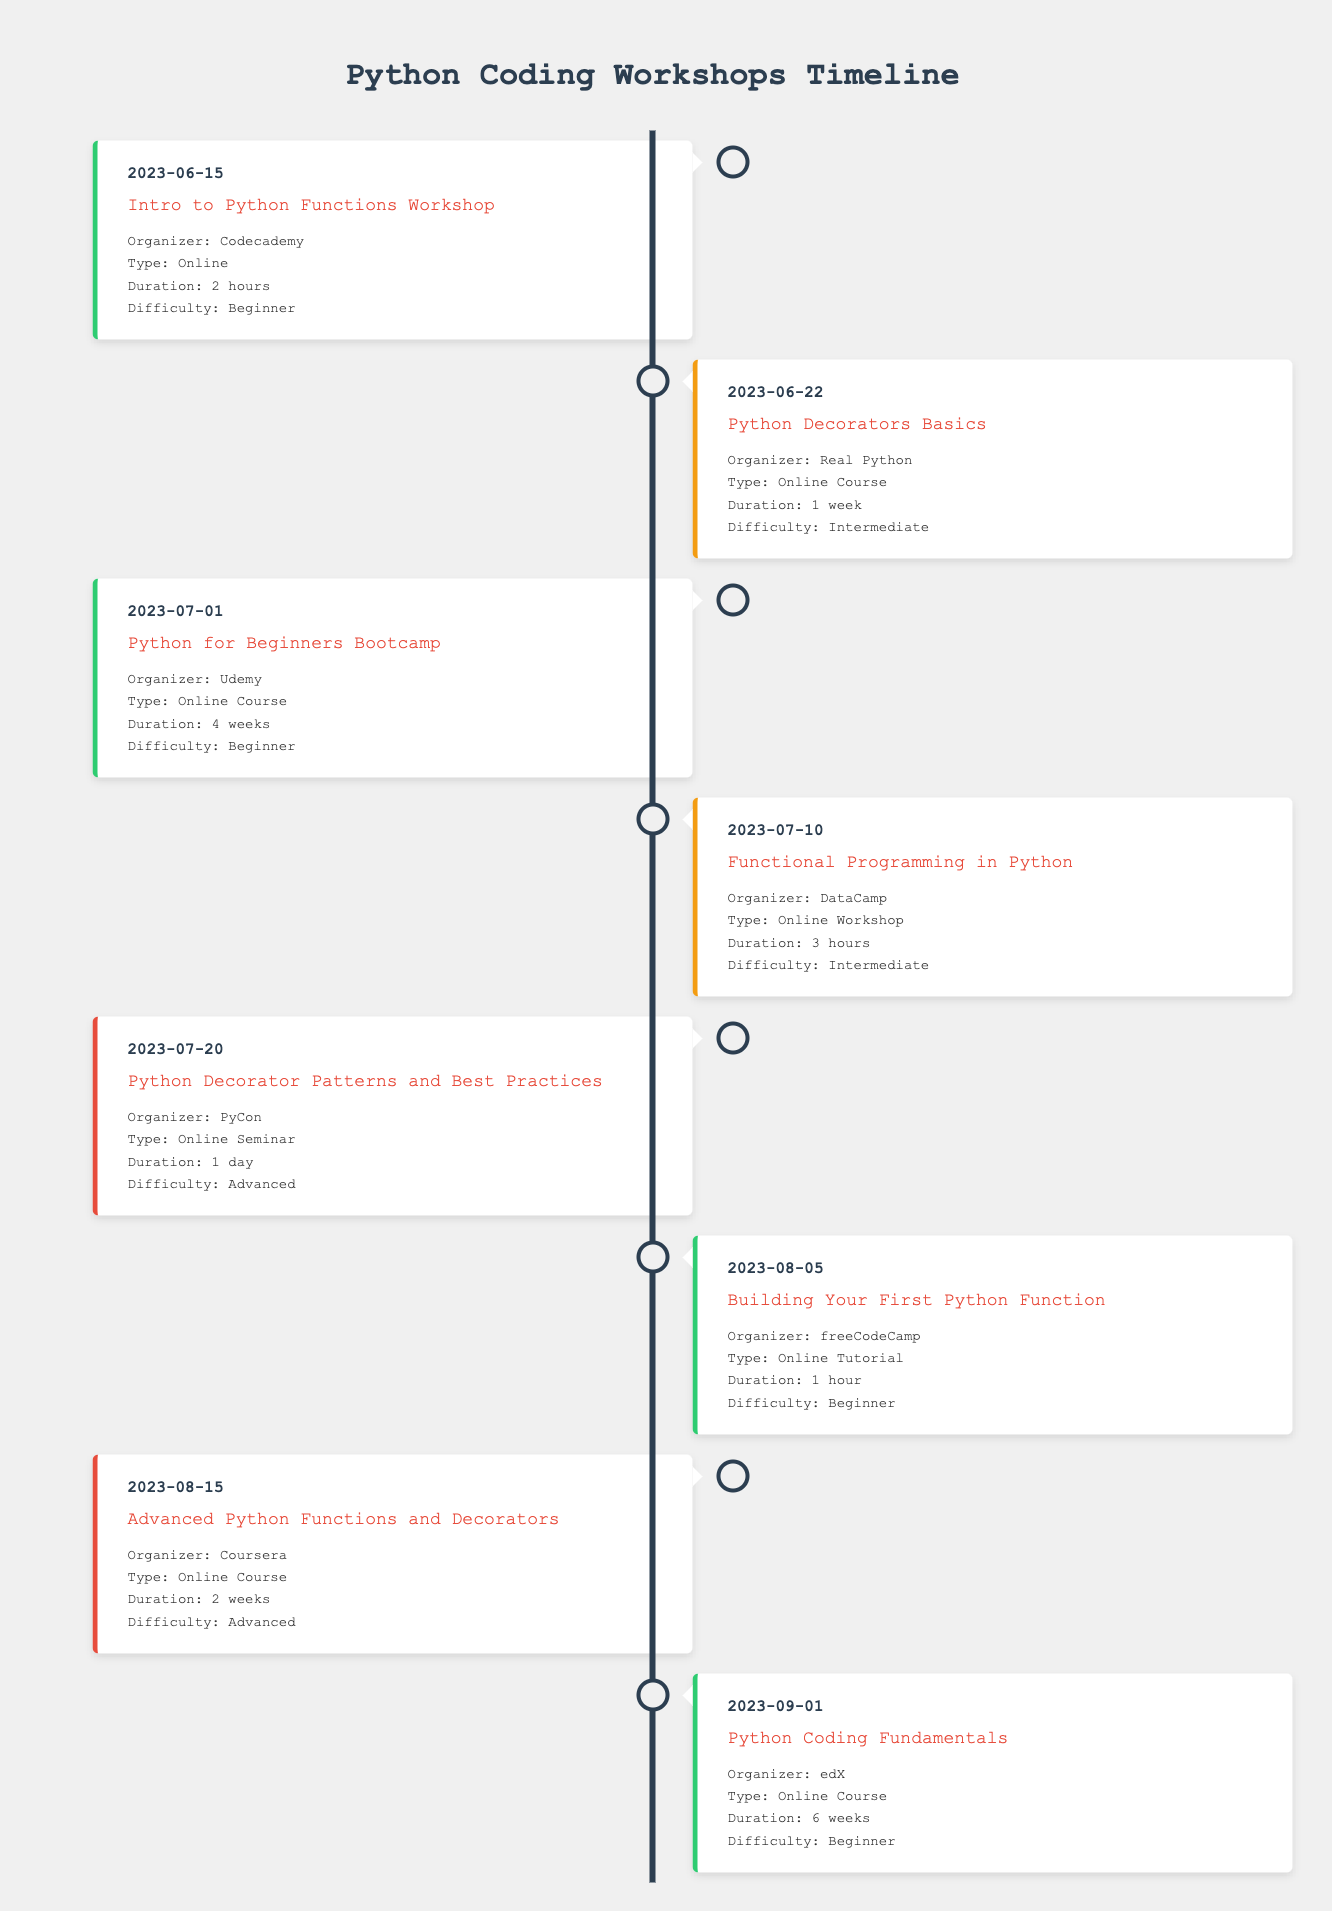What is the date of the "Intro to Python Functions Workshop"? The date for this event is explicitly listed in the timeline table next to the event name. The event "Intro to Python Functions Workshop" has "2023-06-15" as its date.
Answer: 2023-06-15 How long is the "Python for Beginners Bootcamp"? The duration of this bootcamp can be found next to the event in the table. The "Python for Beginners Bootcamp" has a duration of "4 weeks" as indicated.
Answer: 4 weeks Which event is organized by Codecademy? This requires looking at the organizer column in the table. By scanning the events, the "Intro to Python Functions Workshop" is listed with Codecademy as the organizer.
Answer: Intro to Python Functions Workshop Is there an event that lasts for 1 day? We can check the duration of all the events in the table. The "Python Decorator Patterns and Best Practices" event has a duration listed as "1 day," confirming that such an event exists.
Answer: Yes What is the average duration of the "Online Course" type events? To find the average, we first identify the courses: the durations are "1 week," "4 weeks," "2 weeks," and "6 weeks." Converting these to a consistent unit (weeks) gives us 1, 4, 2, and 6. Summing these gives 13 weeks across 4 courses, leading to an average of 13/4 = 3.25 weeks.
Answer: 3.25 weeks How many workshops have an intermediate difficulty level? We will count the events listed as intermediate. Looking through the table, we find that there are three events with this difficulty: "Python Decorators Basics," "Functional Programming in Python," and there is an online workshop. Thus, the count is 3.
Answer: 3 What is the earliest date for an event listed in the table? To determine this, we need to compare all the dates listed in the table. Among them, "2023-06-15" is the earliest date, which corresponds to the "Intro to Python Functions Workshop."
Answer: 2023-06-15 Are there any events specifically focused on decorators? We can check the event titles in the table for mentions of decorators. The "Python Decorators Basics" and "Advanced Python Functions and Decorators" both contain "decorators," confirming that there are multiple such events.
Answer: Yes What is the total duration of all beginner-level events? First, we identify the beginner events and their durations: "2 hours," "4 weeks," "1 hour," and "6 weeks." Converting all durations to hours where necessary (1 week = 168 hours) gives: 2, 168, 1, and 168. Summing them (2 + 168 + 1 + 168) gives a total of 339 hours.
Answer: 339 hours 